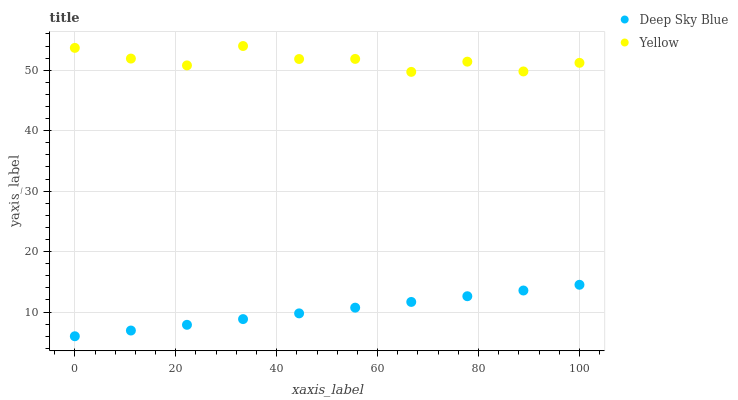Does Deep Sky Blue have the minimum area under the curve?
Answer yes or no. Yes. Does Yellow have the maximum area under the curve?
Answer yes or no. Yes. Does Deep Sky Blue have the maximum area under the curve?
Answer yes or no. No. Is Deep Sky Blue the smoothest?
Answer yes or no. Yes. Is Yellow the roughest?
Answer yes or no. Yes. Is Deep Sky Blue the roughest?
Answer yes or no. No. Does Deep Sky Blue have the lowest value?
Answer yes or no. Yes. Does Yellow have the highest value?
Answer yes or no. Yes. Does Deep Sky Blue have the highest value?
Answer yes or no. No. Is Deep Sky Blue less than Yellow?
Answer yes or no. Yes. Is Yellow greater than Deep Sky Blue?
Answer yes or no. Yes. Does Deep Sky Blue intersect Yellow?
Answer yes or no. No. 